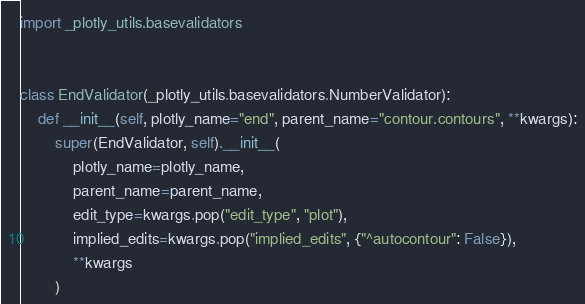Convert code to text. <code><loc_0><loc_0><loc_500><loc_500><_Python_>import _plotly_utils.basevalidators


class EndValidator(_plotly_utils.basevalidators.NumberValidator):
    def __init__(self, plotly_name="end", parent_name="contour.contours", **kwargs):
        super(EndValidator, self).__init__(
            plotly_name=plotly_name,
            parent_name=parent_name,
            edit_type=kwargs.pop("edit_type", "plot"),
            implied_edits=kwargs.pop("implied_edits", {"^autocontour": False}),
            **kwargs
        )
</code> 